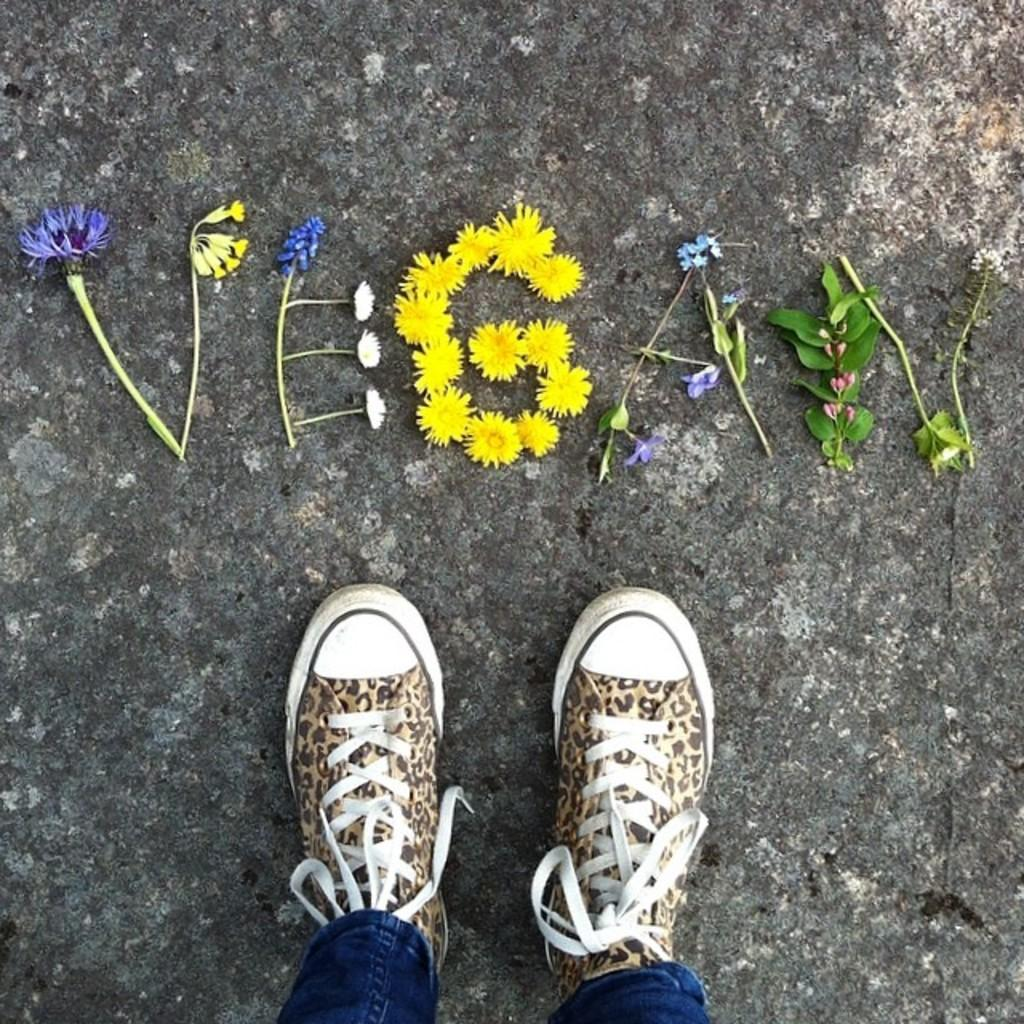What body parts are visible in the image? There are human legs and shoes in the image. What type of plants can be seen in the image? There are flowers and leaves in the image. What is the price of the office furniture in the image? There is no office furniture present in the image, so it is not possible to determine the price. 